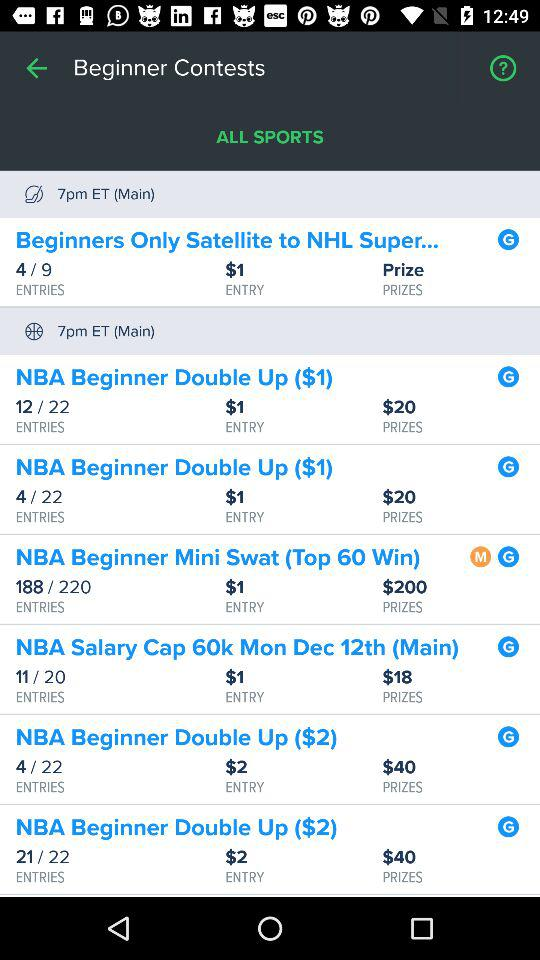What's the main time? The main time is 7 p.m. in Eastern Time. 